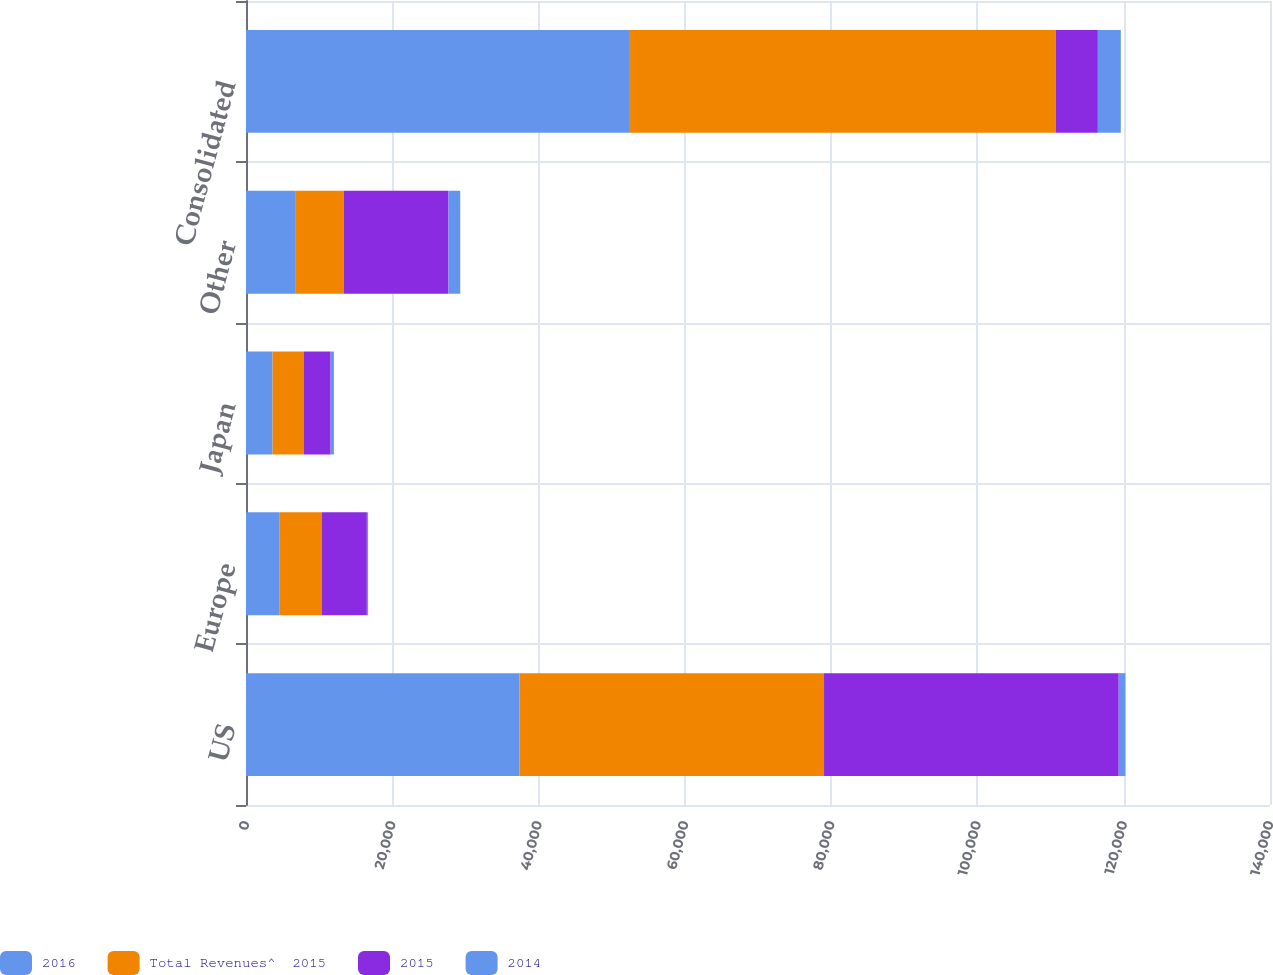<chart> <loc_0><loc_0><loc_500><loc_500><stacked_bar_chart><ecel><fcel>US<fcel>Europe<fcel>Japan<fcel>Other<fcel>Consolidated<nl><fcel>2016<fcel>37405<fcel>4613<fcel>3636<fcel>6713<fcel>52367<nl><fcel>Total Revenues^  2015<fcel>41623<fcel>5772<fcel>4293<fcel>6639<fcel>58327<nl><fcel>2015<fcel>40291<fcel>6140<fcel>3641<fcel>14334<fcel>5772<nl><fcel>2014<fcel>912<fcel>171<fcel>449<fcel>1603<fcel>3135<nl></chart> 